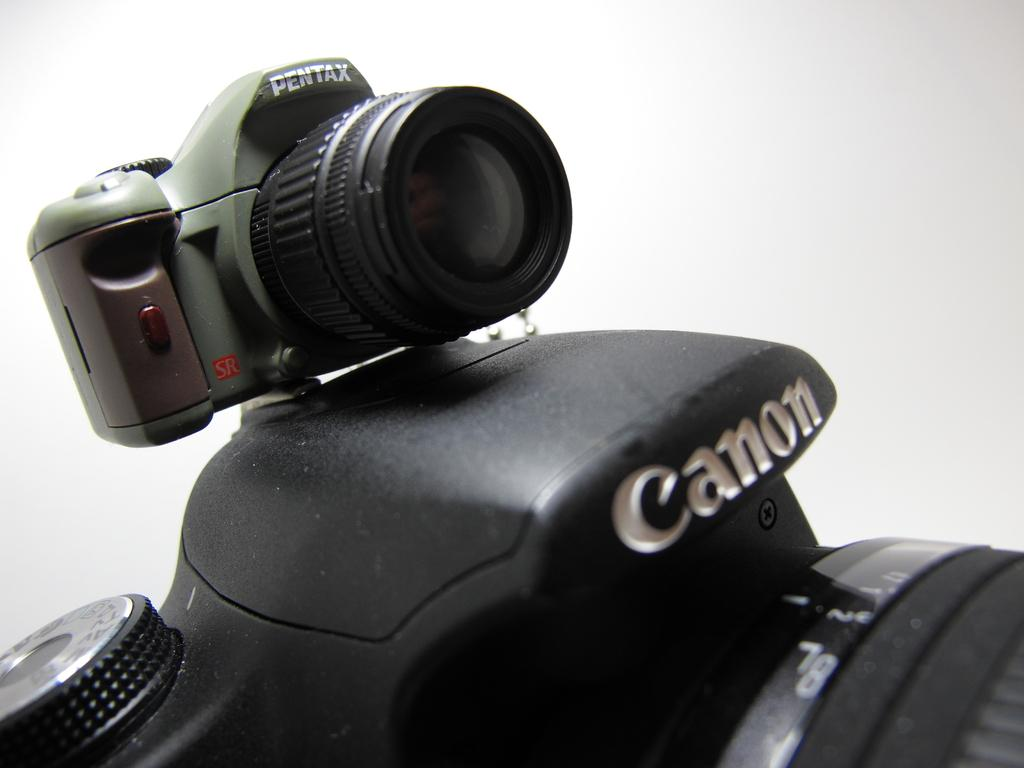What type of cameras are visible in the image? There is a PENTAX camera and a CANON camera in the image. What color is the background of the image? The background of the image is white. Can you tell me how many dogs are present in the image? There are no dogs present in the image. What type of control panel is visible on the cameras in the image? The image does not show any control panels on the cameras; it only shows the cameras themselves. 